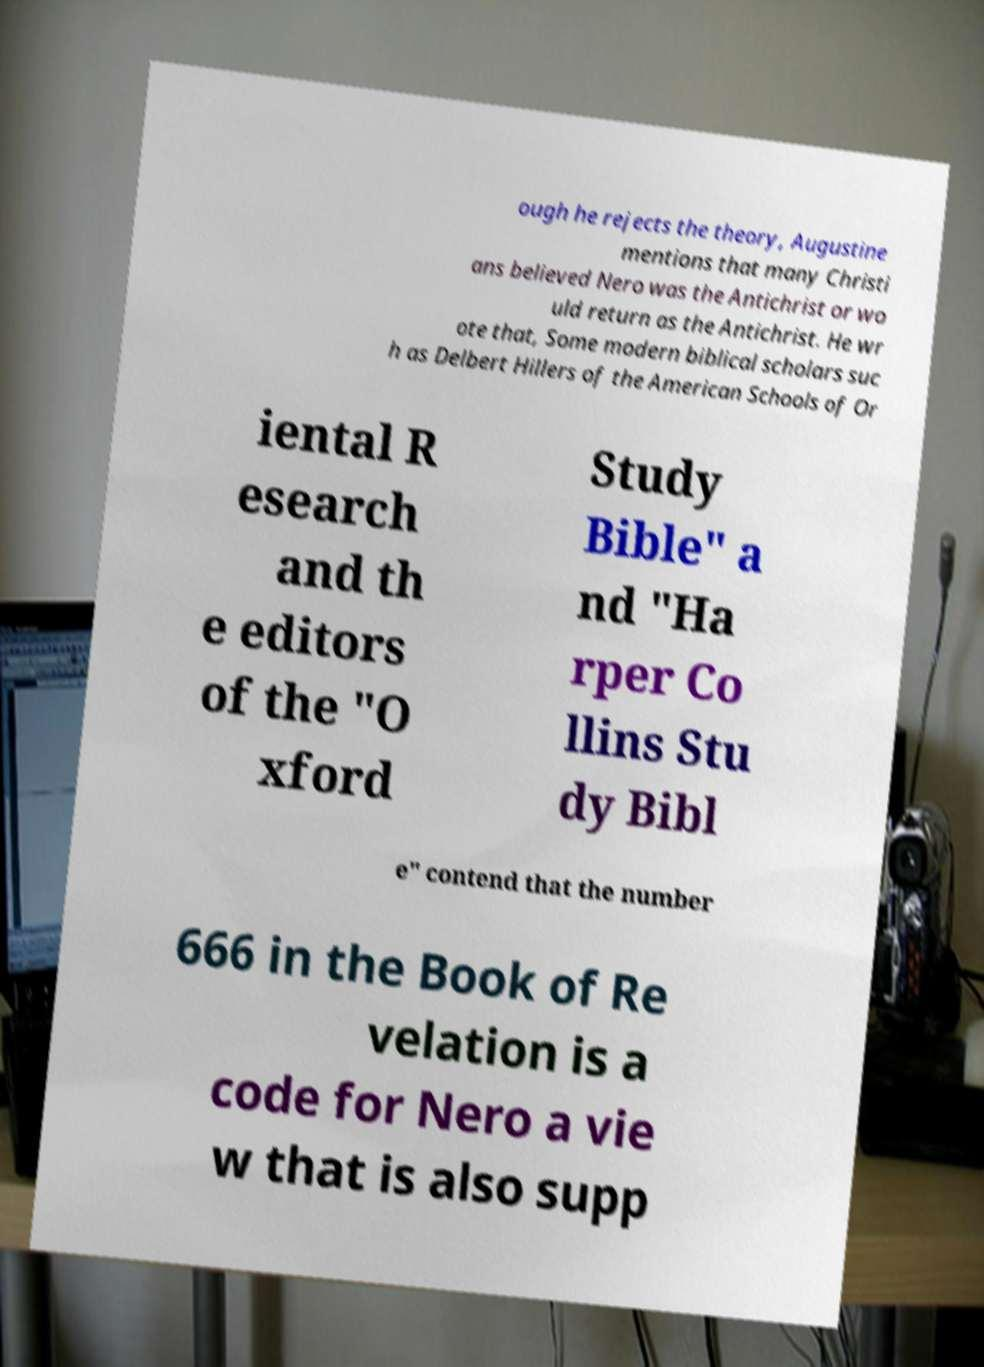Could you extract and type out the text from this image? ough he rejects the theory, Augustine mentions that many Christi ans believed Nero was the Antichrist or wo uld return as the Antichrist. He wr ote that, Some modern biblical scholars suc h as Delbert Hillers of the American Schools of Or iental R esearch and th e editors of the "O xford Study Bible" a nd "Ha rper Co llins Stu dy Bibl e" contend that the number 666 in the Book of Re velation is a code for Nero a vie w that is also supp 